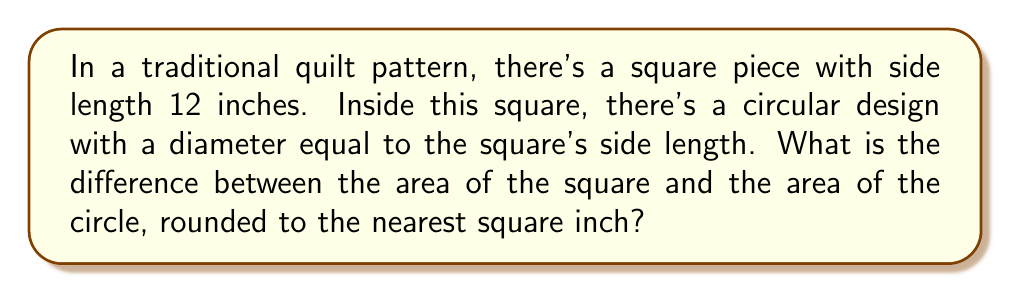Could you help me with this problem? Let's approach this step-by-step:

1. Calculate the area of the square:
   $$A_{square} = s^2 = 12^2 = 144 \text{ square inches}$$

2. Calculate the area of the circle:
   The diameter of the circle is equal to the side of the square, so the radius is half of that.
   $$r = \frac{12}{2} = 6 \text{ inches}$$
   Now we can use the formula for the area of a circle:
   $$A_{circle} = \pi r^2 = \pi (6^2) = 36\pi \text{ square inches}$$

3. Calculate the difference between the areas:
   $$A_{difference} = A_{square} - A_{circle} = 144 - 36\pi$$

4. Compute the numerical value:
   $$A_{difference} = 144 - 36\pi \approx 144 - 113.10 = 30.90 \text{ square inches}$$

5. Round to the nearest square inch:
   $$A_{difference} \approx 31 \text{ square inches}$$
Answer: 31 square inches 